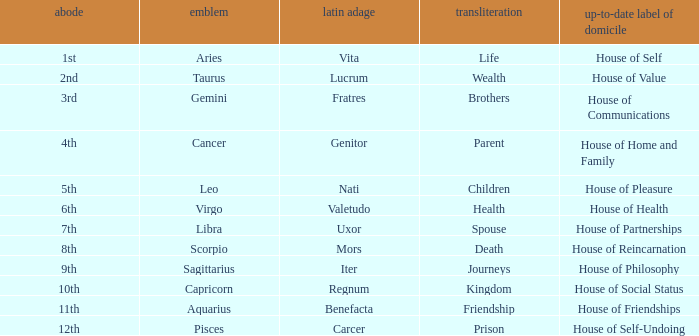What is the Latin motto of the sign that translates to spouse? Uxor. 